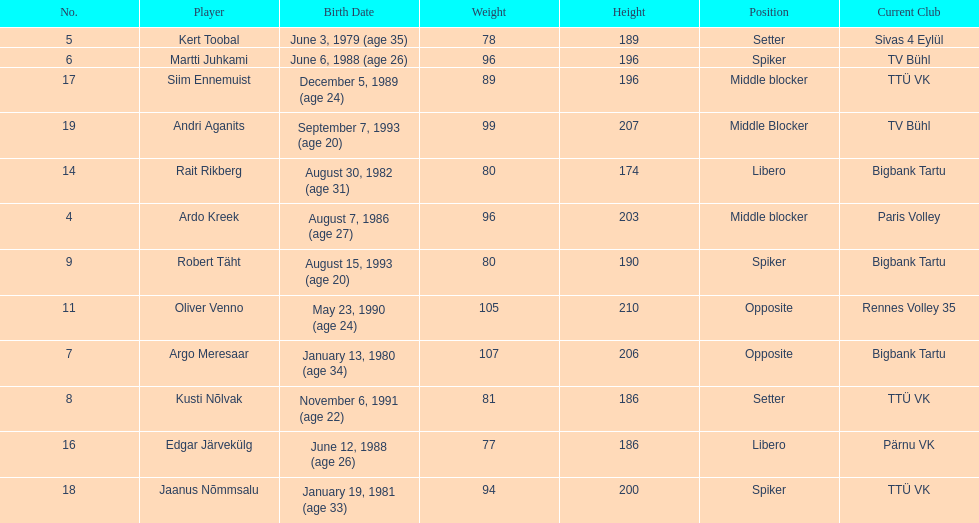What are the total number of players from france? 2. 